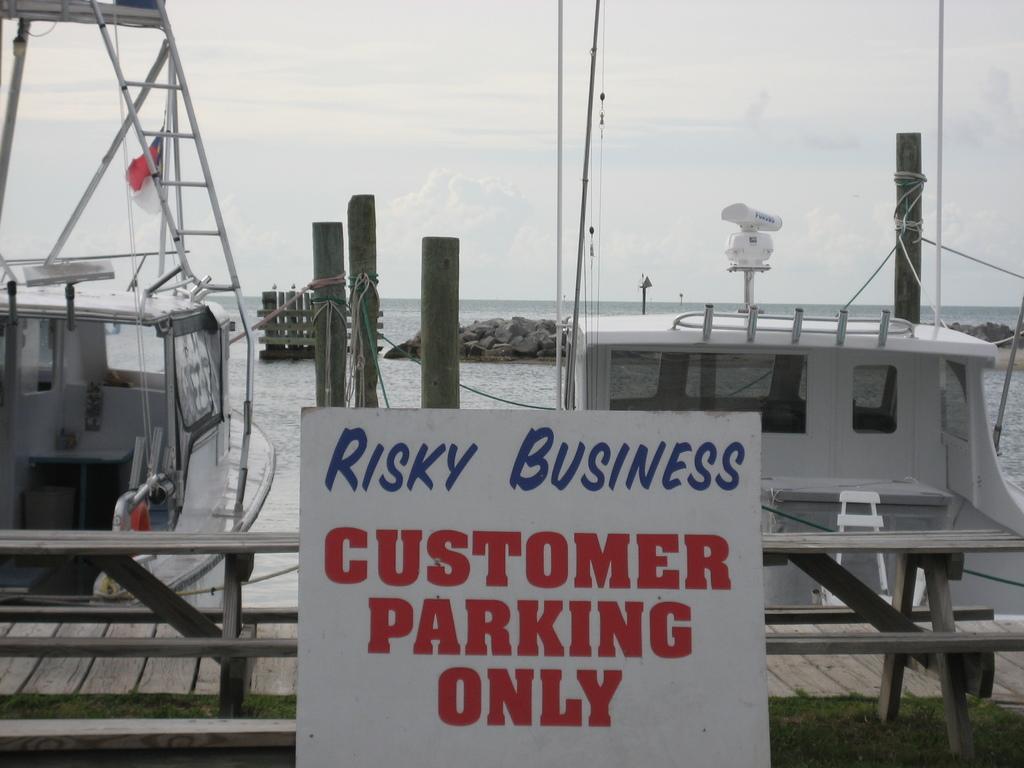Can you describe this image briefly? In the image we can see there are boats in the water. Here we can see poles, rope and the stones. We can even see the poster and text on it. Here we can see a fence, wooden footpath, grass and the cloudy sky. 